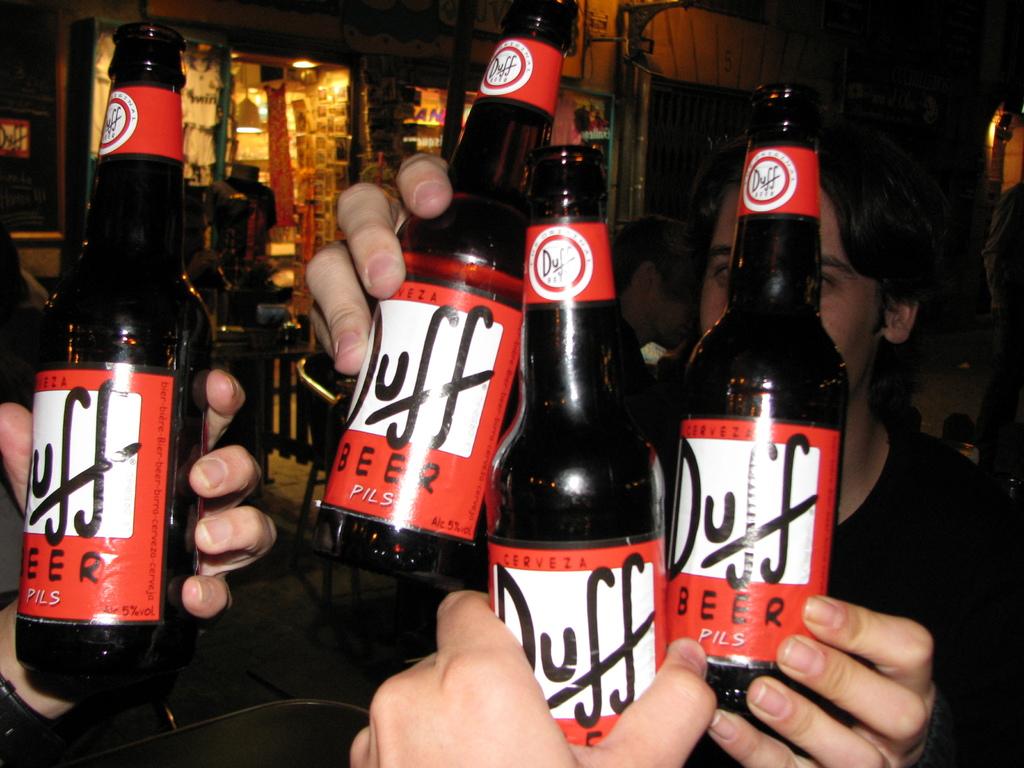What is the name of the beer?
Ensure brevity in your answer.  Duff. 